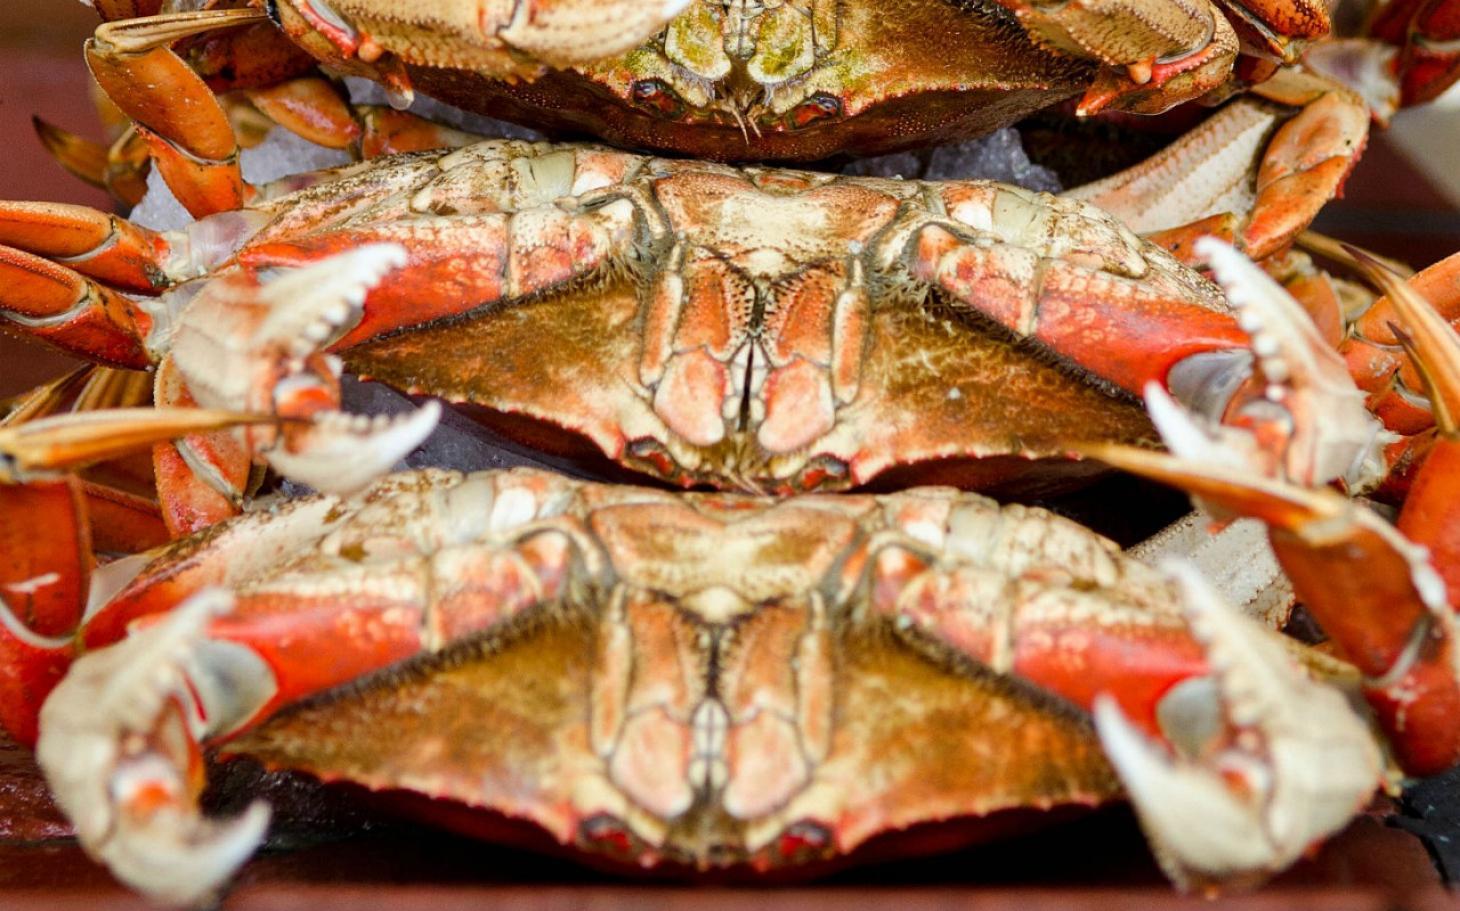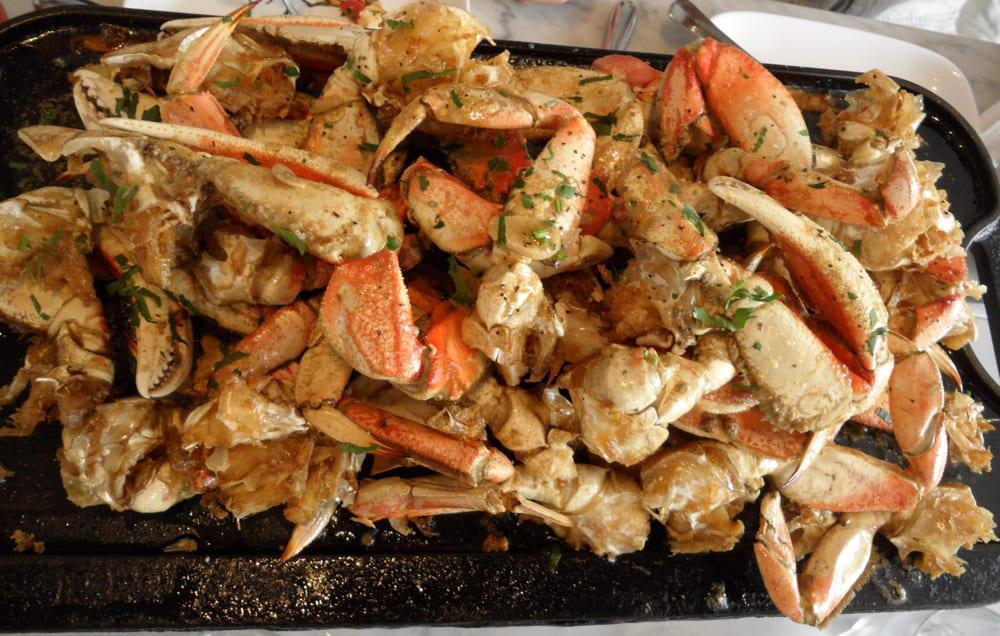The first image is the image on the left, the second image is the image on the right. Evaluate the accuracy of this statement regarding the images: "One image features crab and two silver bowls of liquid on a round black tray, and the other image features crab on a rectangular black tray.". Is it true? Answer yes or no. No. The first image is the image on the left, the second image is the image on the right. For the images shown, is this caption "there is a meal of crab on a plate with two silver bowls with condiments in them" true? Answer yes or no. No. 